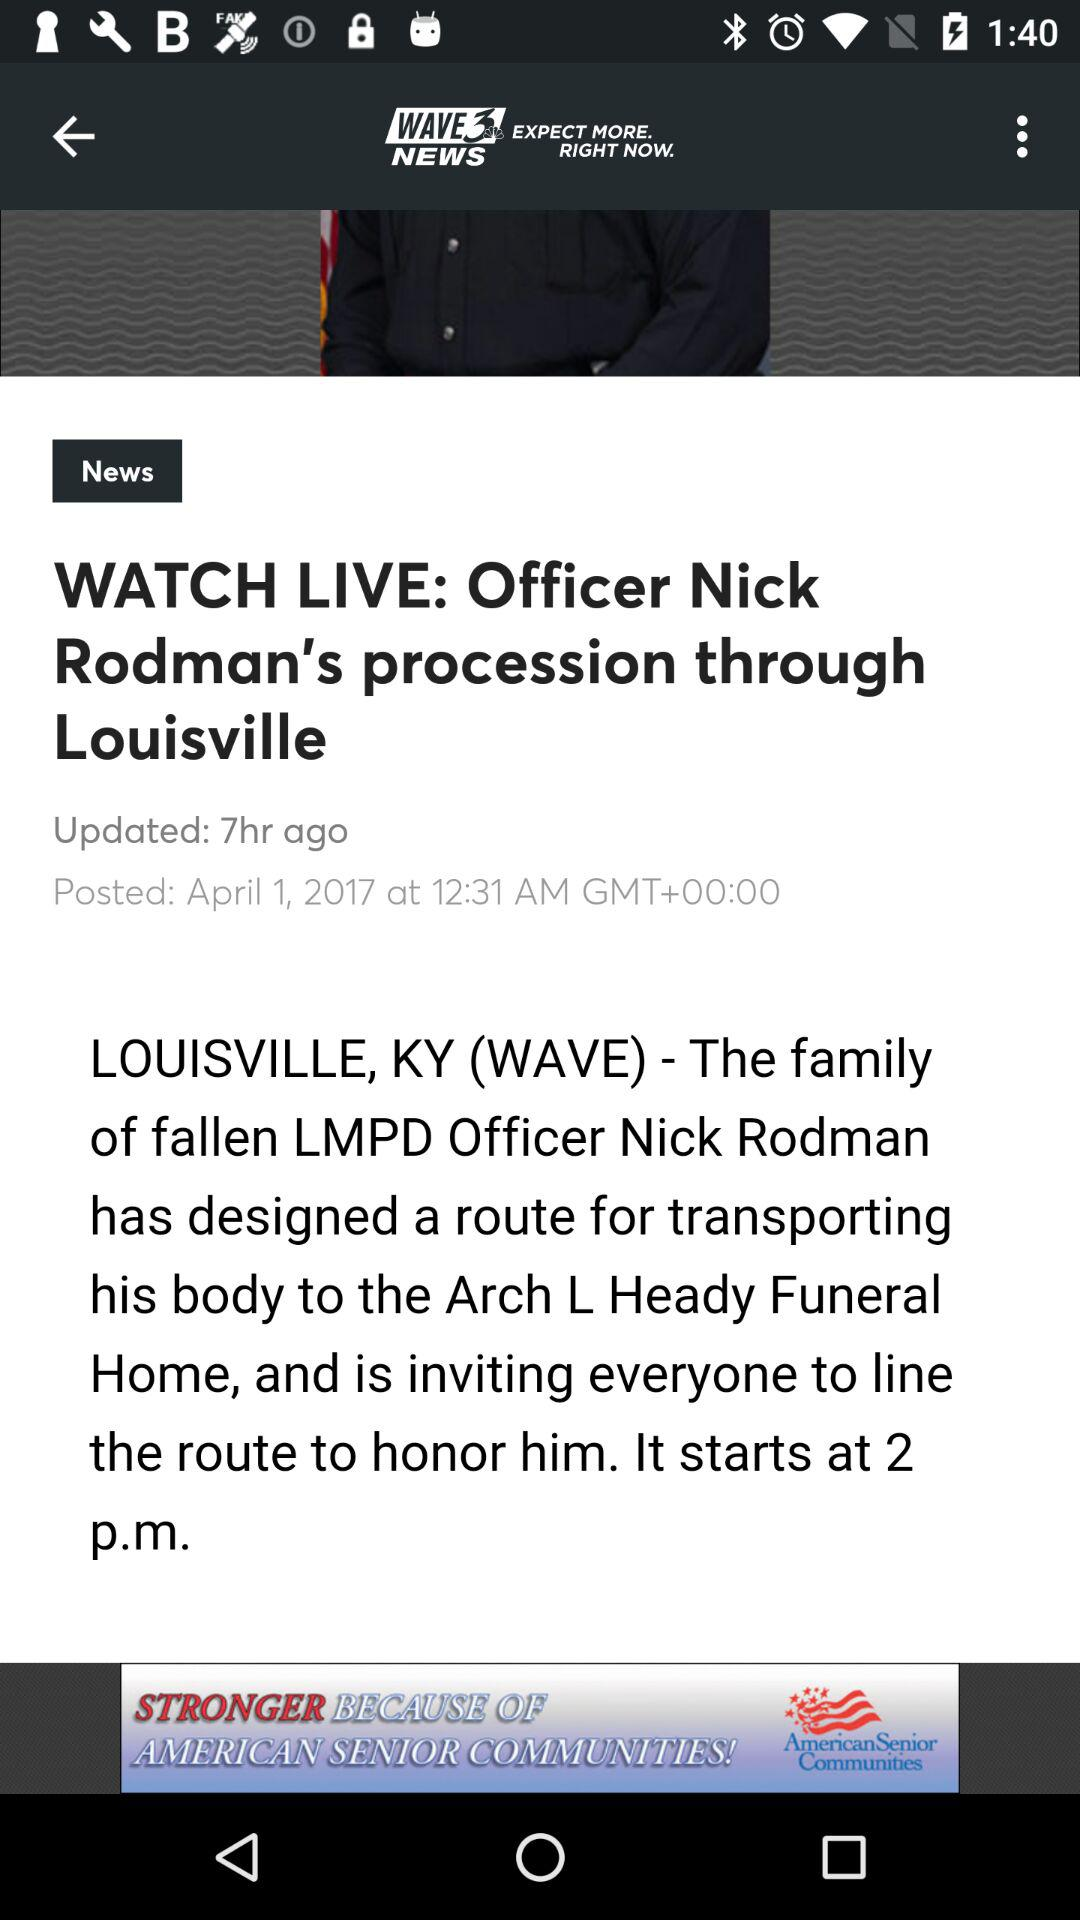What is the posted date of the article? The posted date of the article is April 1, 2017. 